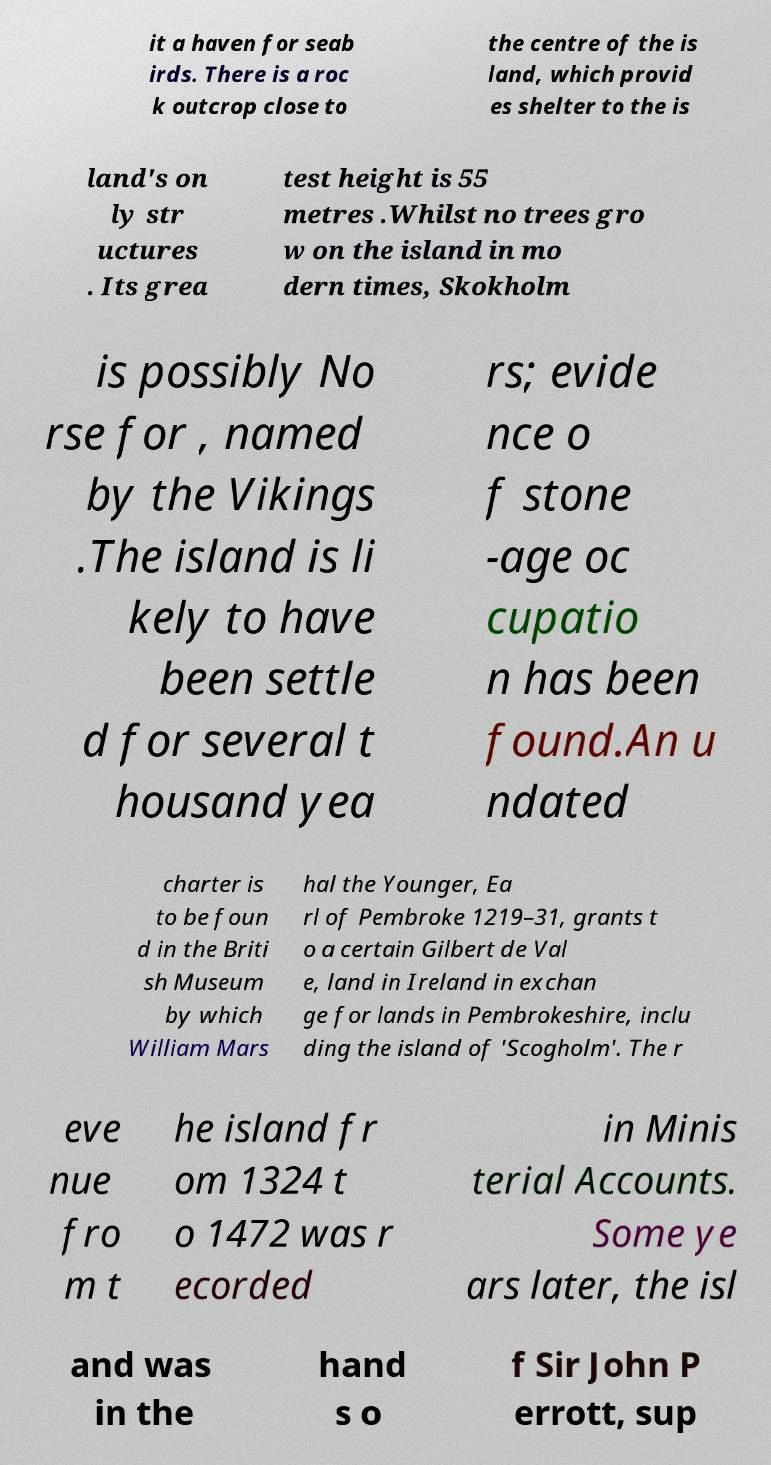Can you accurately transcribe the text from the provided image for me? it a haven for seab irds. There is a roc k outcrop close to the centre of the is land, which provid es shelter to the is land's on ly str uctures . Its grea test height is 55 metres .Whilst no trees gro w on the island in mo dern times, Skokholm is possibly No rse for , named by the Vikings .The island is li kely to have been settle d for several t housand yea rs; evide nce o f stone -age oc cupatio n has been found.An u ndated charter is to be foun d in the Briti sh Museum by which William Mars hal the Younger, Ea rl of Pembroke 1219–31, grants t o a certain Gilbert de Val e, land in Ireland in exchan ge for lands in Pembrokeshire, inclu ding the island of 'Scogholm'. The r eve nue fro m t he island fr om 1324 t o 1472 was r ecorded in Minis terial Accounts. Some ye ars later, the isl and was in the hand s o f Sir John P errott, sup 